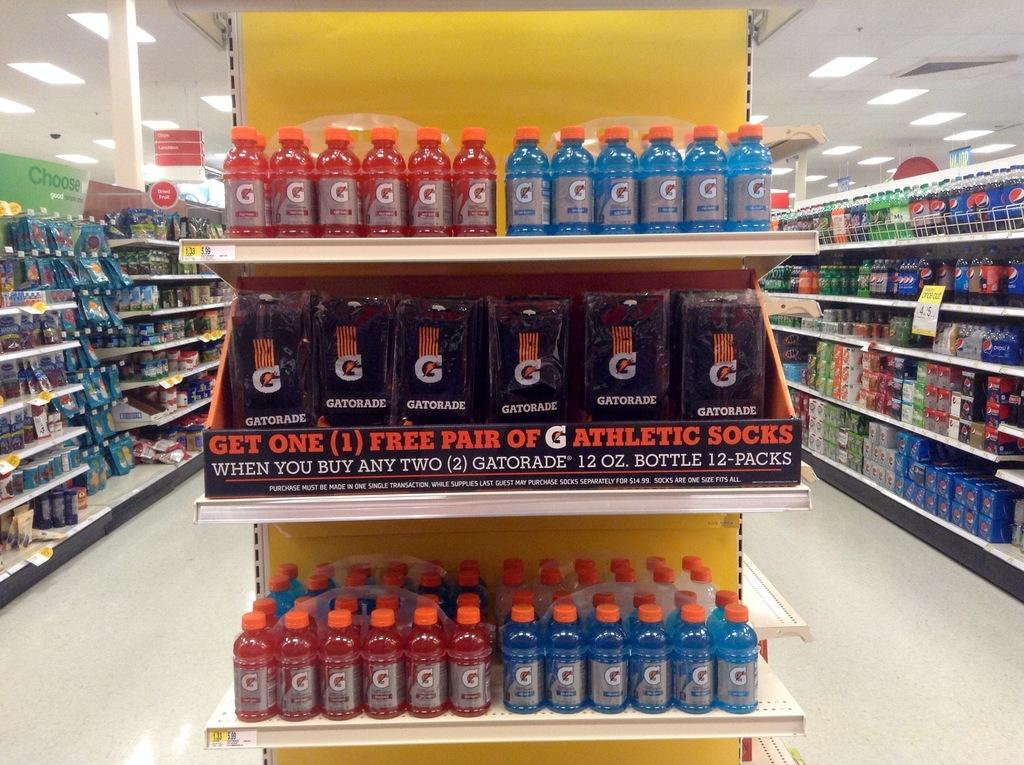<image>
Give a short and clear explanation of the subsequent image. A grocery store display for Gatorade, advertising Get one free pair of athletic socks. 